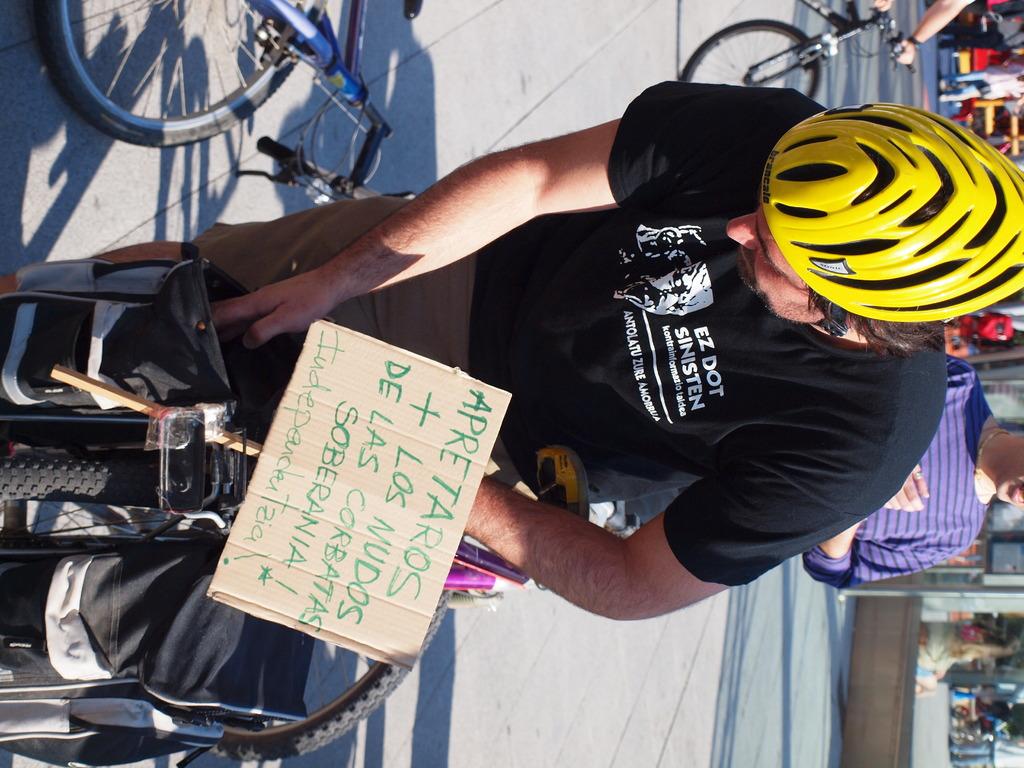What is the brand of this man's helmet?
Your answer should be compact. Brancale. 